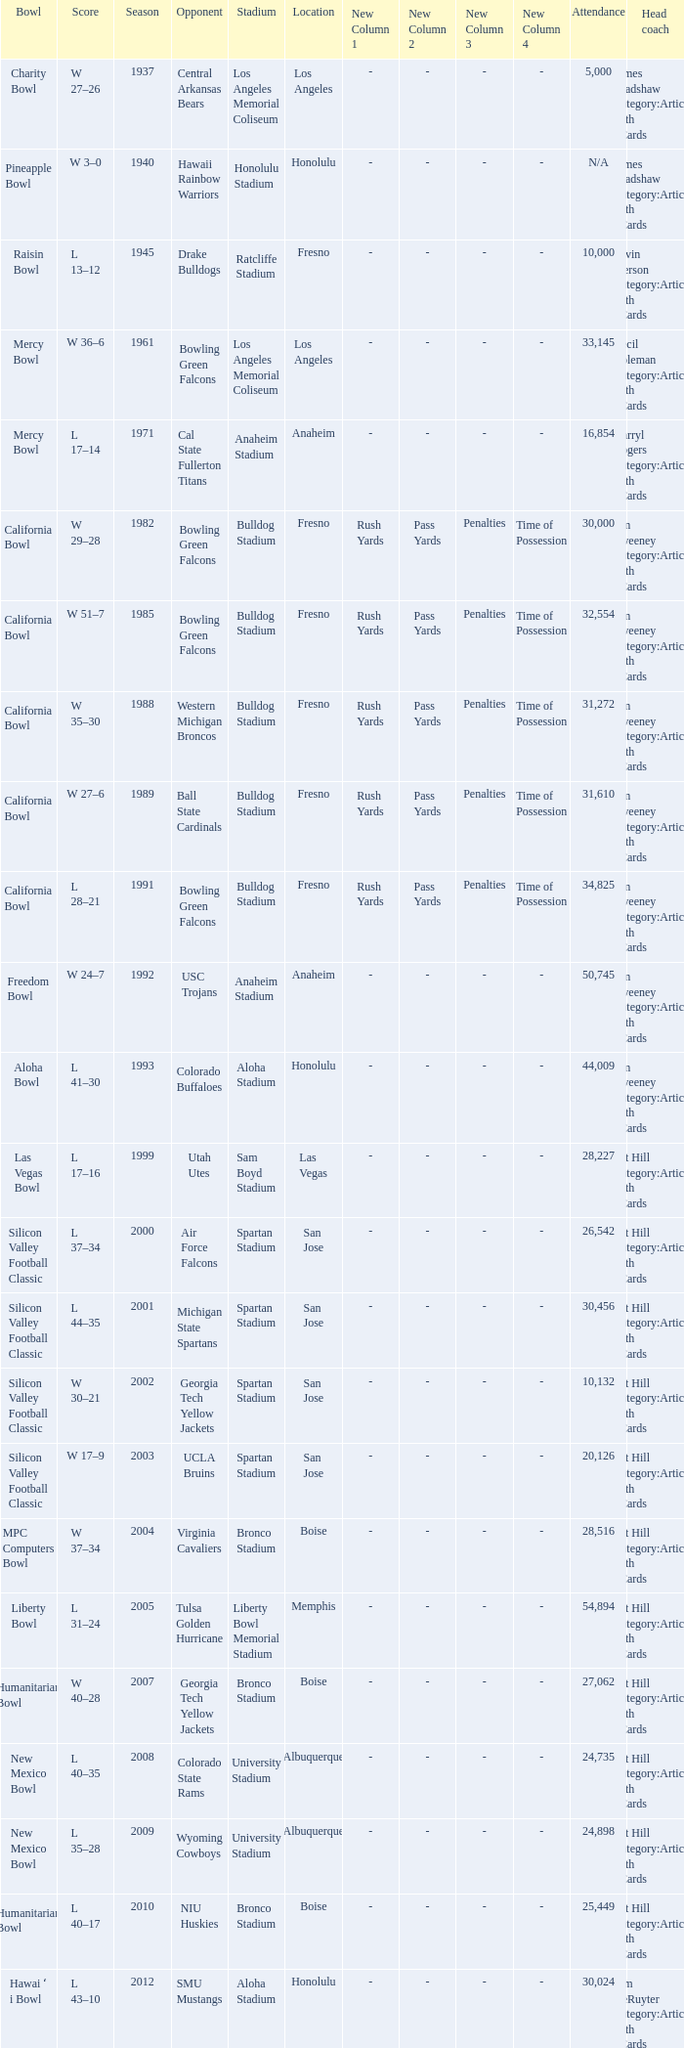Where was the California bowl played with 30,000 attending? Fresno. 